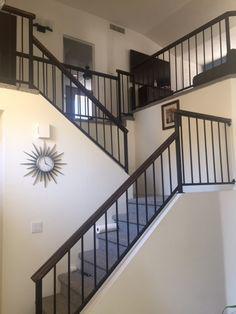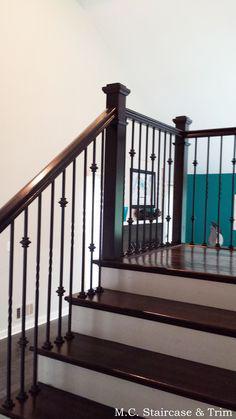The first image is the image on the left, the second image is the image on the right. For the images displayed, is the sentence "All the vertical stairway railings are black." factually correct? Answer yes or no. Yes. The first image is the image on the left, the second image is the image on the right. Analyze the images presented: Is the assertion "One image in the pair shows carpeted stairs and the other shows uncarpeted stairs." valid? Answer yes or no. Yes. 